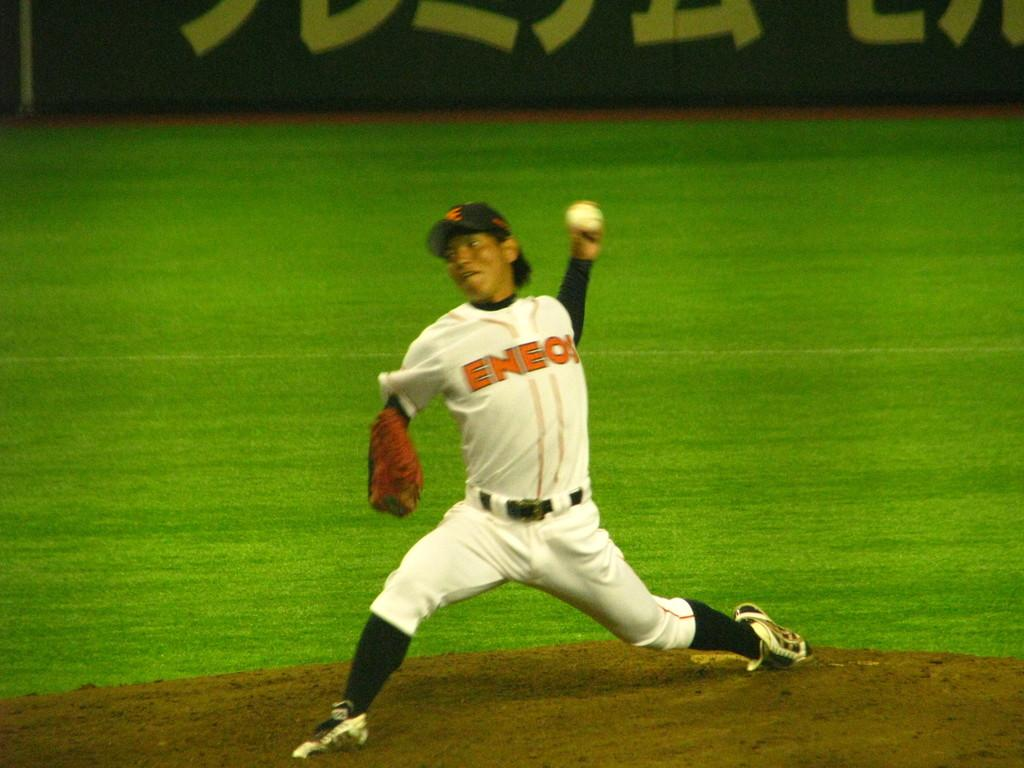<image>
Create a compact narrative representing the image presented. The Eneos pitcher is just about to release the baseball. 